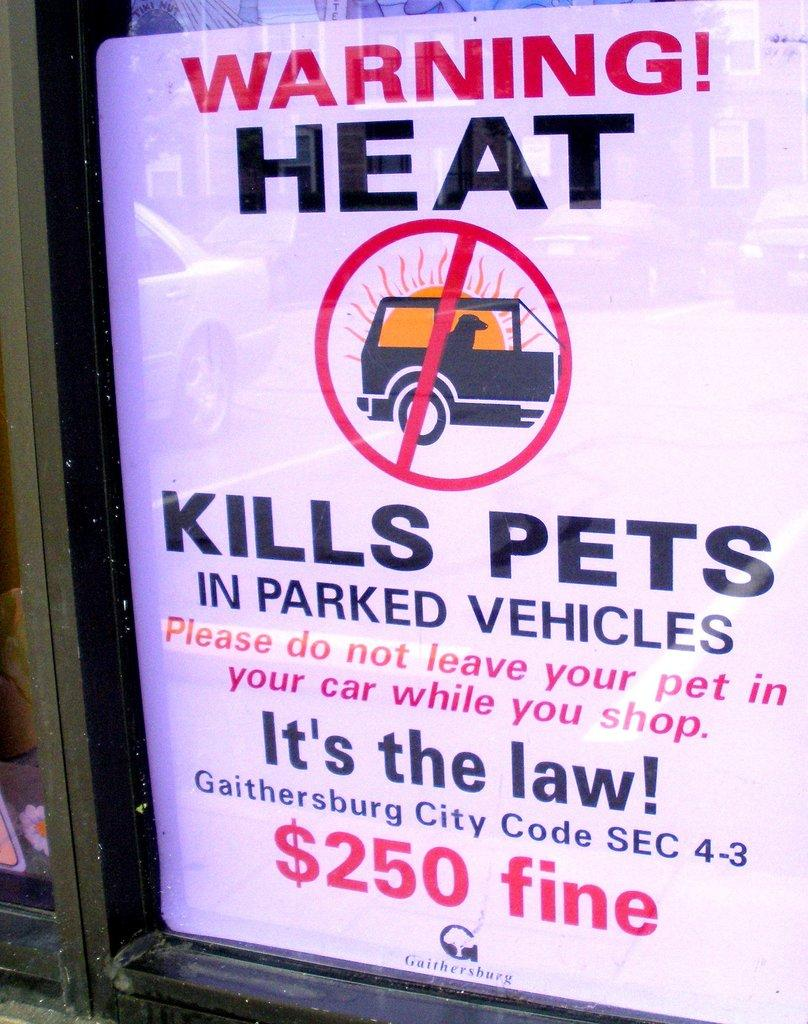What is the main subject of the image? The main subject of the image is a digital advertisement. Where is the digital advertisement located in the image? The digital advertisement is present over a place. What type of earth can be seen in the image? There is no earth or soil present in the image; it features a digital advertisement. How many mines are visible in the image? There are no mines present in the image. 